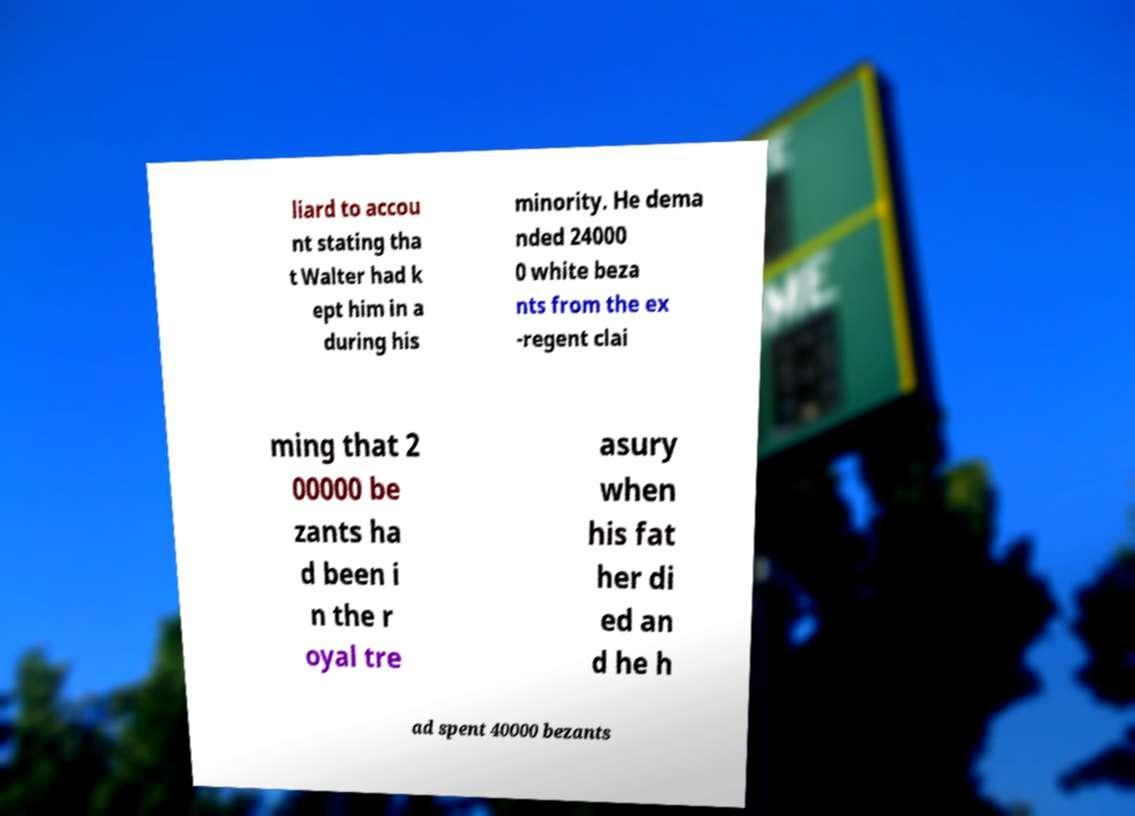Can you accurately transcribe the text from the provided image for me? liard to accou nt stating tha t Walter had k ept him in a during his minority. He dema nded 24000 0 white beza nts from the ex -regent clai ming that 2 00000 be zants ha d been i n the r oyal tre asury when his fat her di ed an d he h ad spent 40000 bezants 